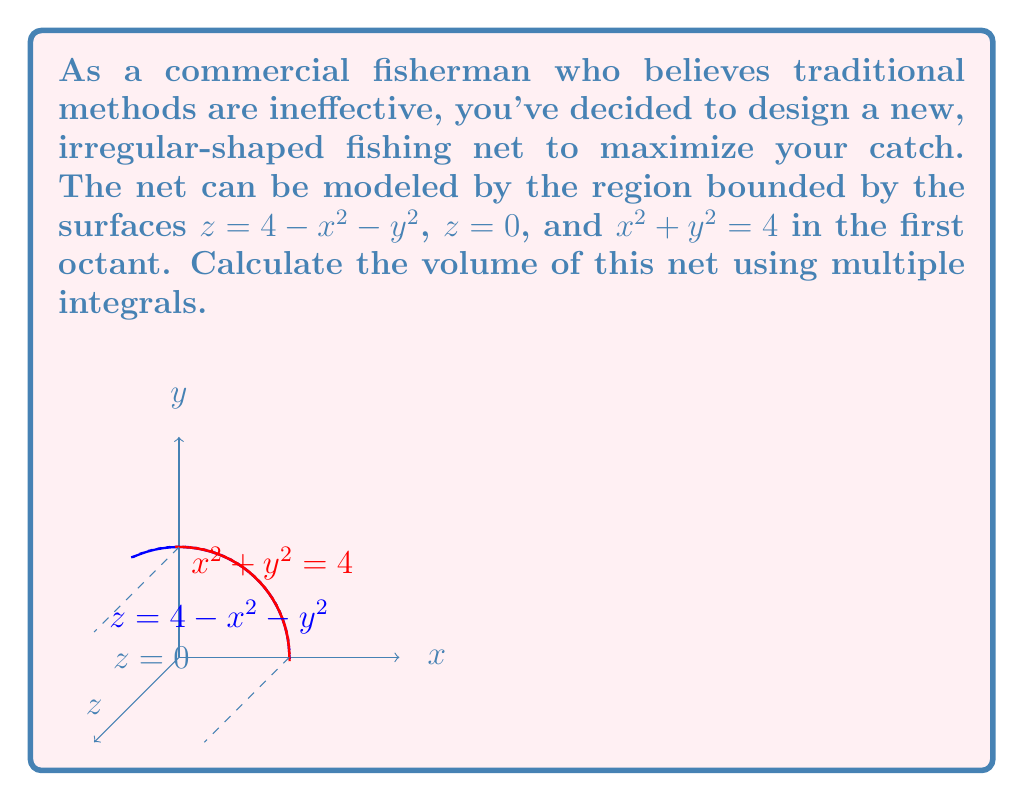Provide a solution to this math problem. Let's approach this problem step-by-step:

1) First, we need to set up our triple integral. The volume will be given by:

   $$V = \iiint_R dV$$

   where $R$ is the region bounded by the given surfaces.

2) Due to the cylindrical symmetry of the problem, it's best to use cylindrical coordinates:
   $x = r\cos\theta$, $y = r\sin\theta$, $z = z$

3) In cylindrical coordinates, our bounds are:
   $0 \leq r \leq 2$ (from $x^2 + y^2 = 4$)
   $0 \leq \theta \leq \frac{\pi}{2}$ (first quadrant in xy-plane)
   $0 \leq z \leq 4 - r^2$ (from $z = 4 - x^2 - y^2$)

4) The volume integral in cylindrical coordinates is:

   $$V = \int_0^{\frac{\pi}{2}} \int_0^2 \int_0^{4-r^2} r \, dz \, dr \, d\theta$$

5) Let's solve the innermost integral first:

   $$V = \int_0^{\frac{\pi}{2}} \int_0^2 r(4-r^2) \, dr \, d\theta$$

6) Now the middle integral:

   $$V = \int_0^{\frac{\pi}{2}} \left[2r^2 - \frac{r^4}{4}\right]_0^2 \, d\theta$$
   $$= \int_0^{\frac{\pi}{2}} \left(8 - 4\right) \, d\theta = 4\int_0^{\frac{\pi}{2}} \, d\theta$$

7) Finally, the outermost integral:

   $$V = 4 \left[\theta\right]_0^{\frac{\pi}{2}} = 4 \cdot \frac{\pi}{2} = 2\pi$$

Therefore, the volume of the net is $2\pi$ cubic units.
Answer: $2\pi$ cubic units 